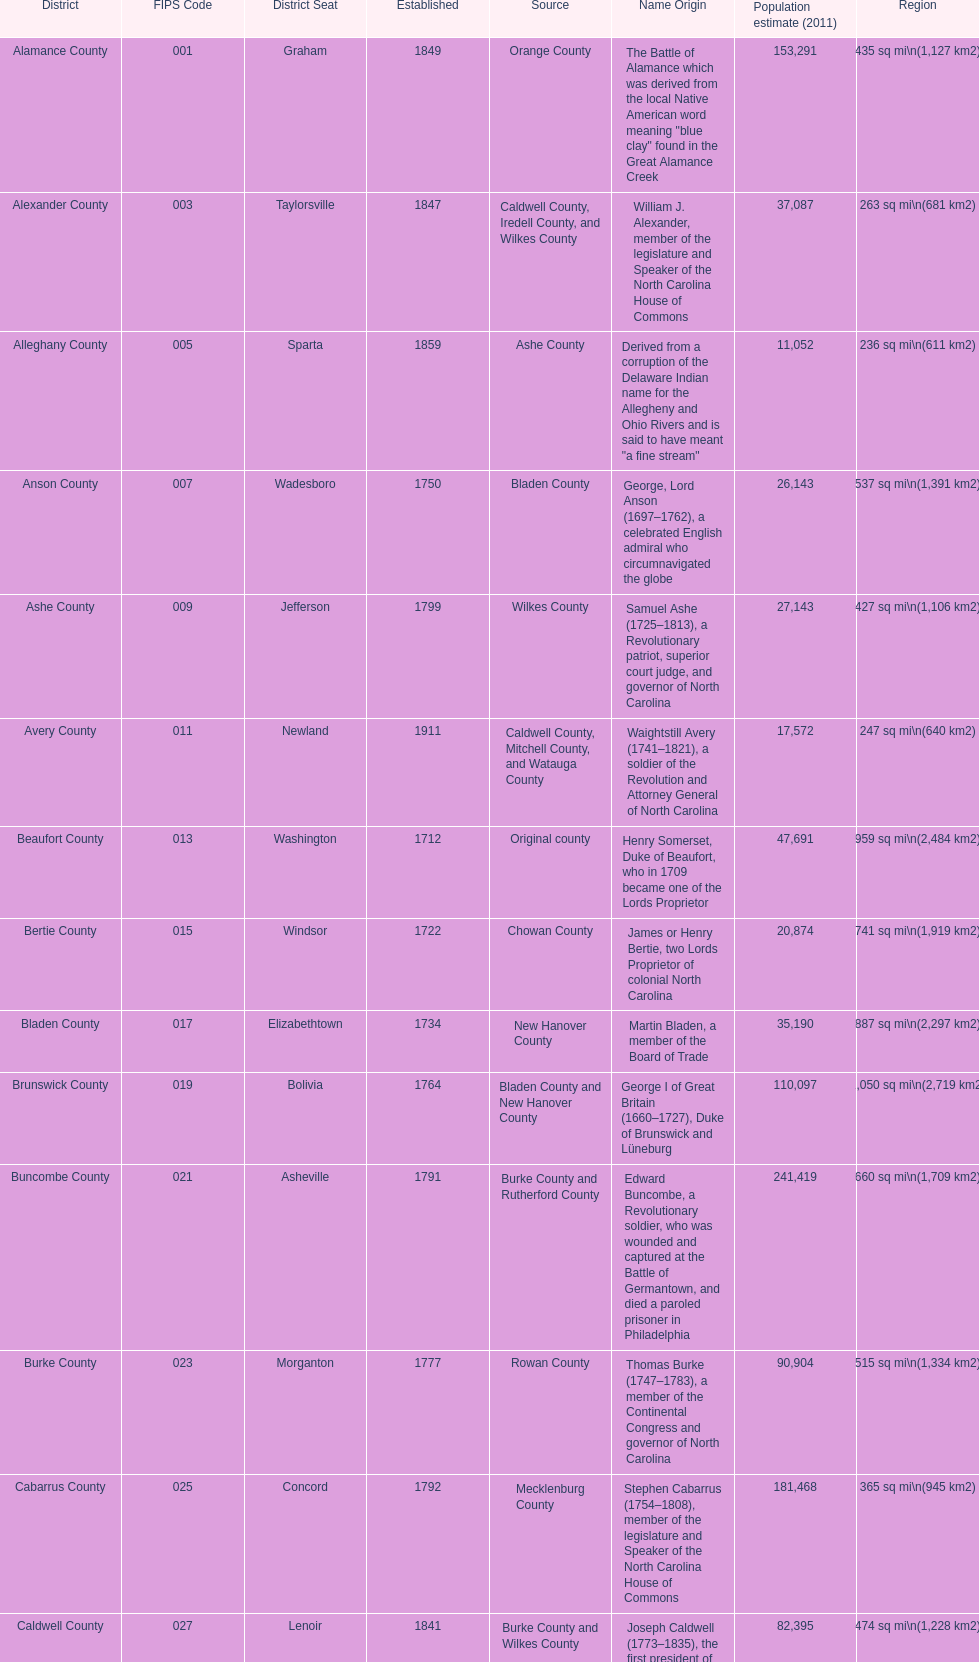What is the total number of counties listed? 100. 